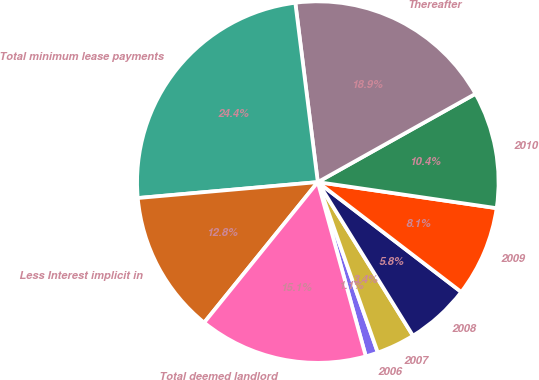<chart> <loc_0><loc_0><loc_500><loc_500><pie_chart><fcel>2006<fcel>2007<fcel>2008<fcel>2009<fcel>2010<fcel>Thereafter<fcel>Total minimum lease payments<fcel>Less Interest implicit in<fcel>Total deemed landlord<nl><fcel>1.11%<fcel>3.44%<fcel>5.77%<fcel>8.1%<fcel>10.43%<fcel>18.86%<fcel>24.42%<fcel>12.77%<fcel>15.1%<nl></chart> 